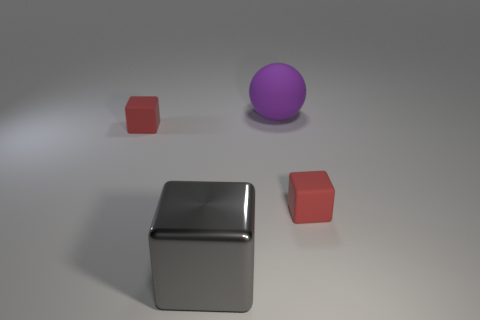Are there any other things that have the same material as the gray thing?
Provide a succinct answer. No. There is a cube that is in front of the red matte cube that is right of the large metal cube; are there any red matte objects in front of it?
Your response must be concise. No. Do the big matte object and the tiny red object that is on the right side of the large purple rubber sphere have the same shape?
Your answer should be compact. No. Does the cube on the right side of the big purple rubber ball have the same color as the tiny object that is on the left side of the purple thing?
Your response must be concise. Yes. What is the color of the other thing that is the same size as the gray object?
Make the answer very short. Purple. How many cubes are left of the big sphere and behind the metal object?
Offer a very short reply. 1. There is a rubber cube that is on the left side of the metallic block; does it have the same size as the red block right of the large rubber sphere?
Offer a very short reply. Yes. There is a rubber cube on the left side of the big metallic object; how big is it?
Offer a very short reply. Small. Is the number of things on the left side of the large gray shiny cube less than the number of large gray shiny cubes on the right side of the purple matte ball?
Provide a short and direct response. No. The cube that is left of the big purple matte ball and behind the metallic object is made of what material?
Keep it short and to the point. Rubber. 